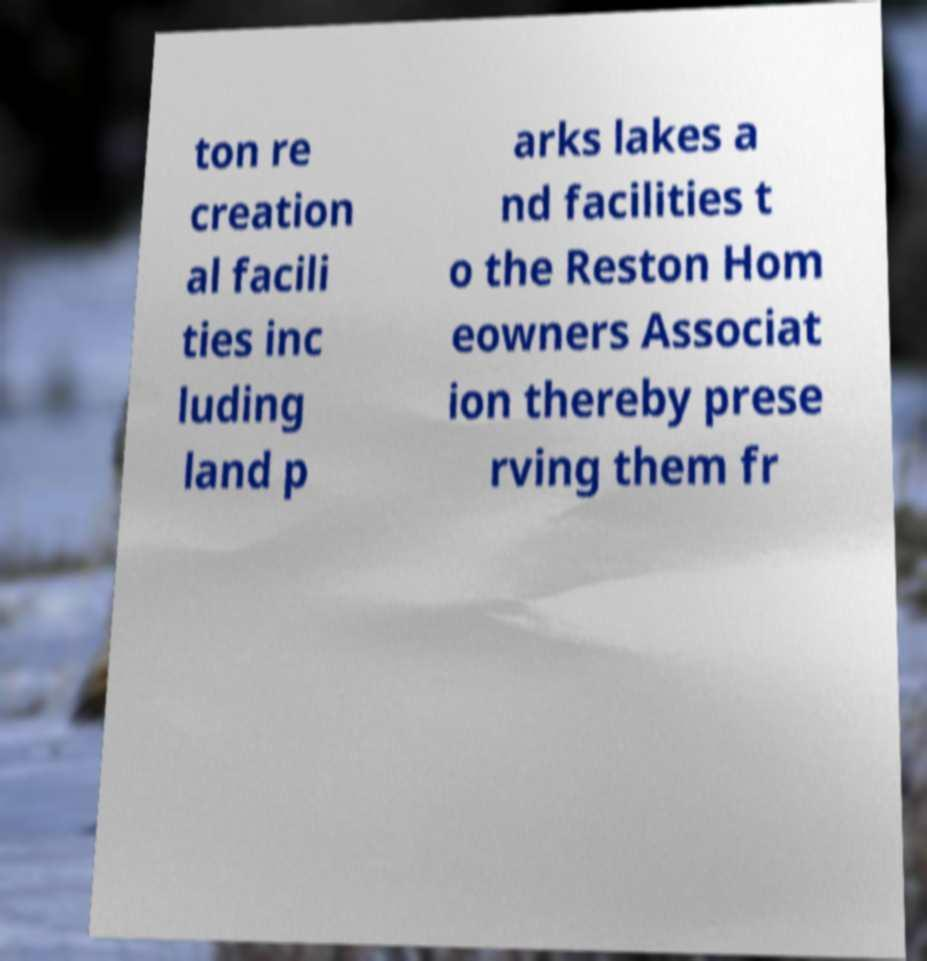For documentation purposes, I need the text within this image transcribed. Could you provide that? ton re creation al facili ties inc luding land p arks lakes a nd facilities t o the Reston Hom eowners Associat ion thereby prese rving them fr 